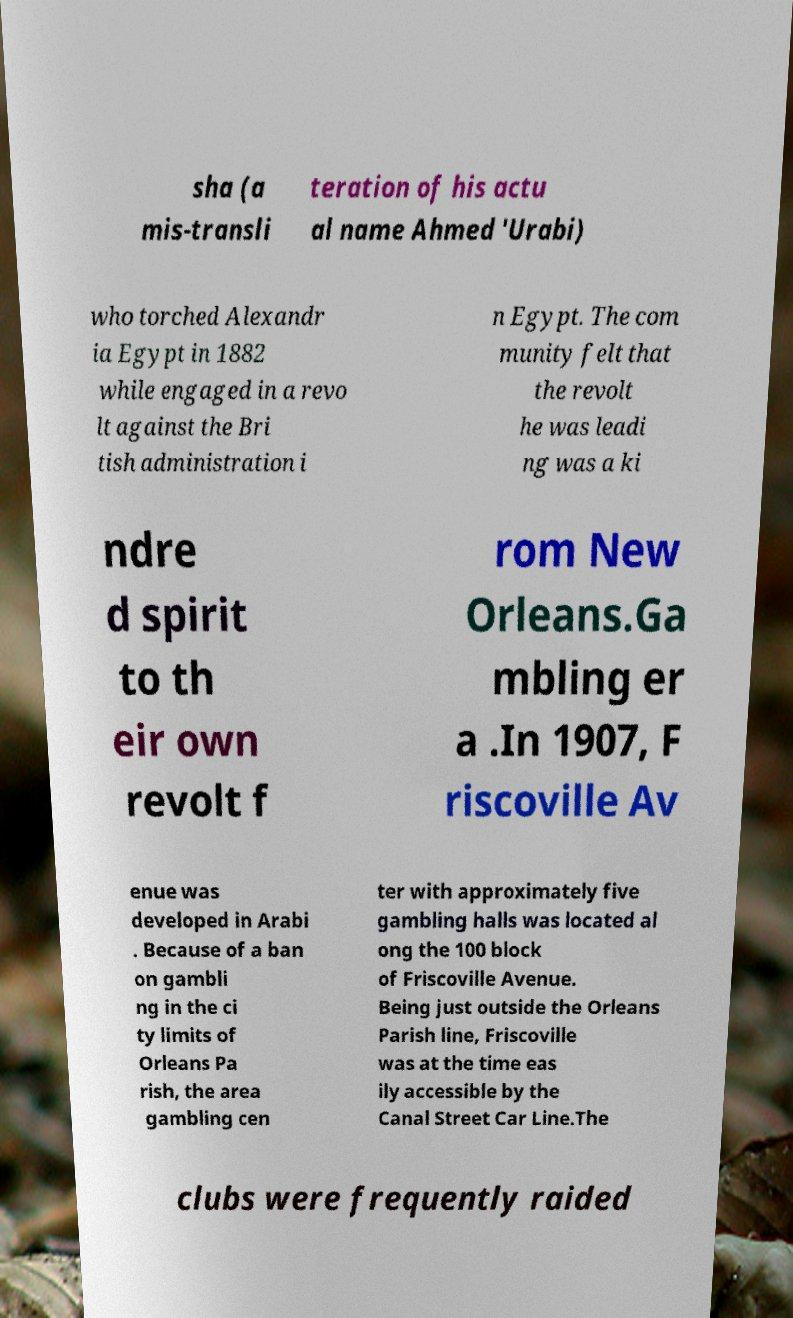Could you extract and type out the text from this image? sha (a mis-transli teration of his actu al name Ahmed 'Urabi) who torched Alexandr ia Egypt in 1882 while engaged in a revo lt against the Bri tish administration i n Egypt. The com munity felt that the revolt he was leadi ng was a ki ndre d spirit to th eir own revolt f rom New Orleans.Ga mbling er a .In 1907, F riscoville Av enue was developed in Arabi . Because of a ban on gambli ng in the ci ty limits of Orleans Pa rish, the area gambling cen ter with approximately five gambling halls was located al ong the 100 block of Friscoville Avenue. Being just outside the Orleans Parish line, Friscoville was at the time eas ily accessible by the Canal Street Car Line.The clubs were frequently raided 